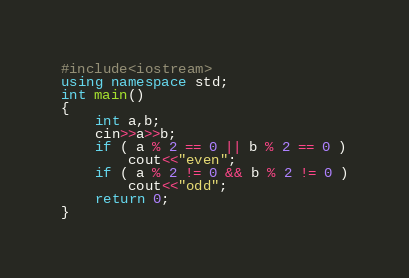<code> <loc_0><loc_0><loc_500><loc_500><_C++_>#include<iostream>
using namespace std;
int main()
{
    int a,b;
    cin>>a>>b;
    if ( a % 2 == 0 || b % 2 == 0 )
        cout<<"even";
    if ( a % 2 != 0 && b % 2 != 0 )
        cout<<"odd";
    return 0;
}
</code> 